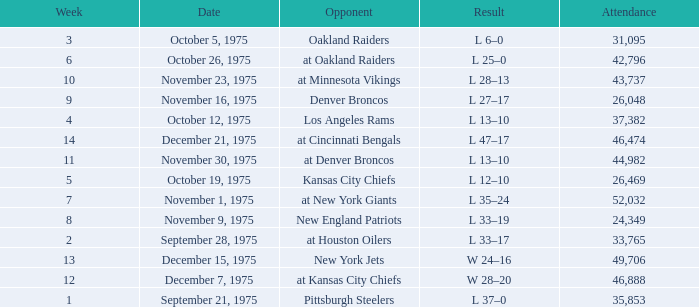What is the lowest Week when the result was l 13–10, November 30, 1975, with more than 44,982 people in attendance? None. 